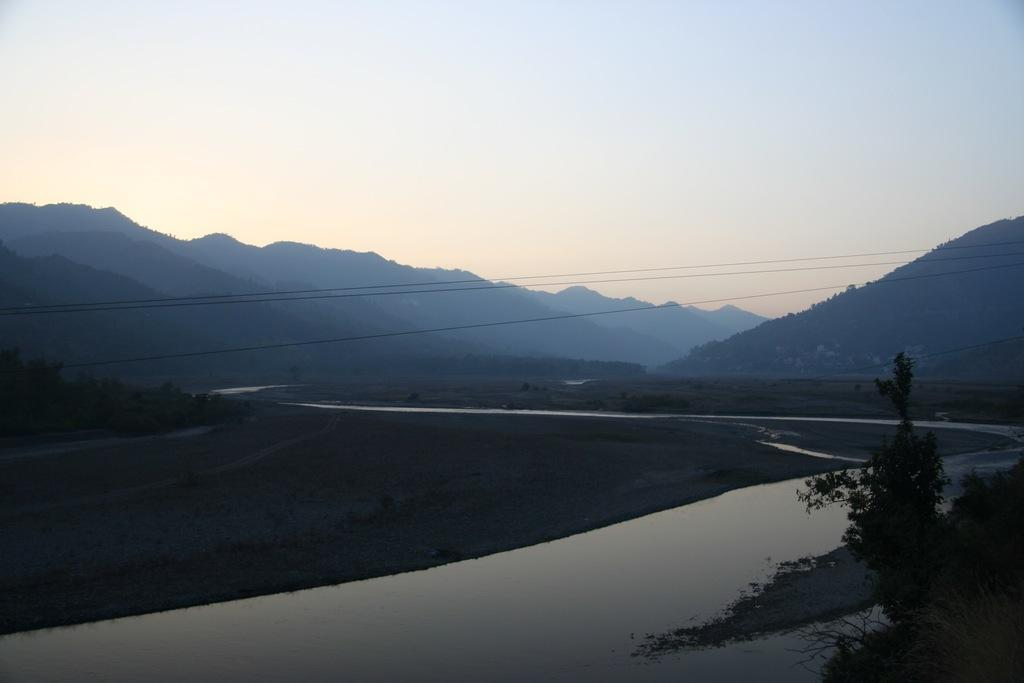What is the primary element in the image? There is water in the image. What type of landscape feature can be seen in the image? There are hills visible in the image. What type of vegetation is present in the image? There are trees in the image. What is visible in the sky in the image? Clouds are present in the sky in the image. What type of apparatus is being used to collect blood samples in the image? There is no apparatus or blood samples present in the image; it features water, hills, trees, and clouds. 